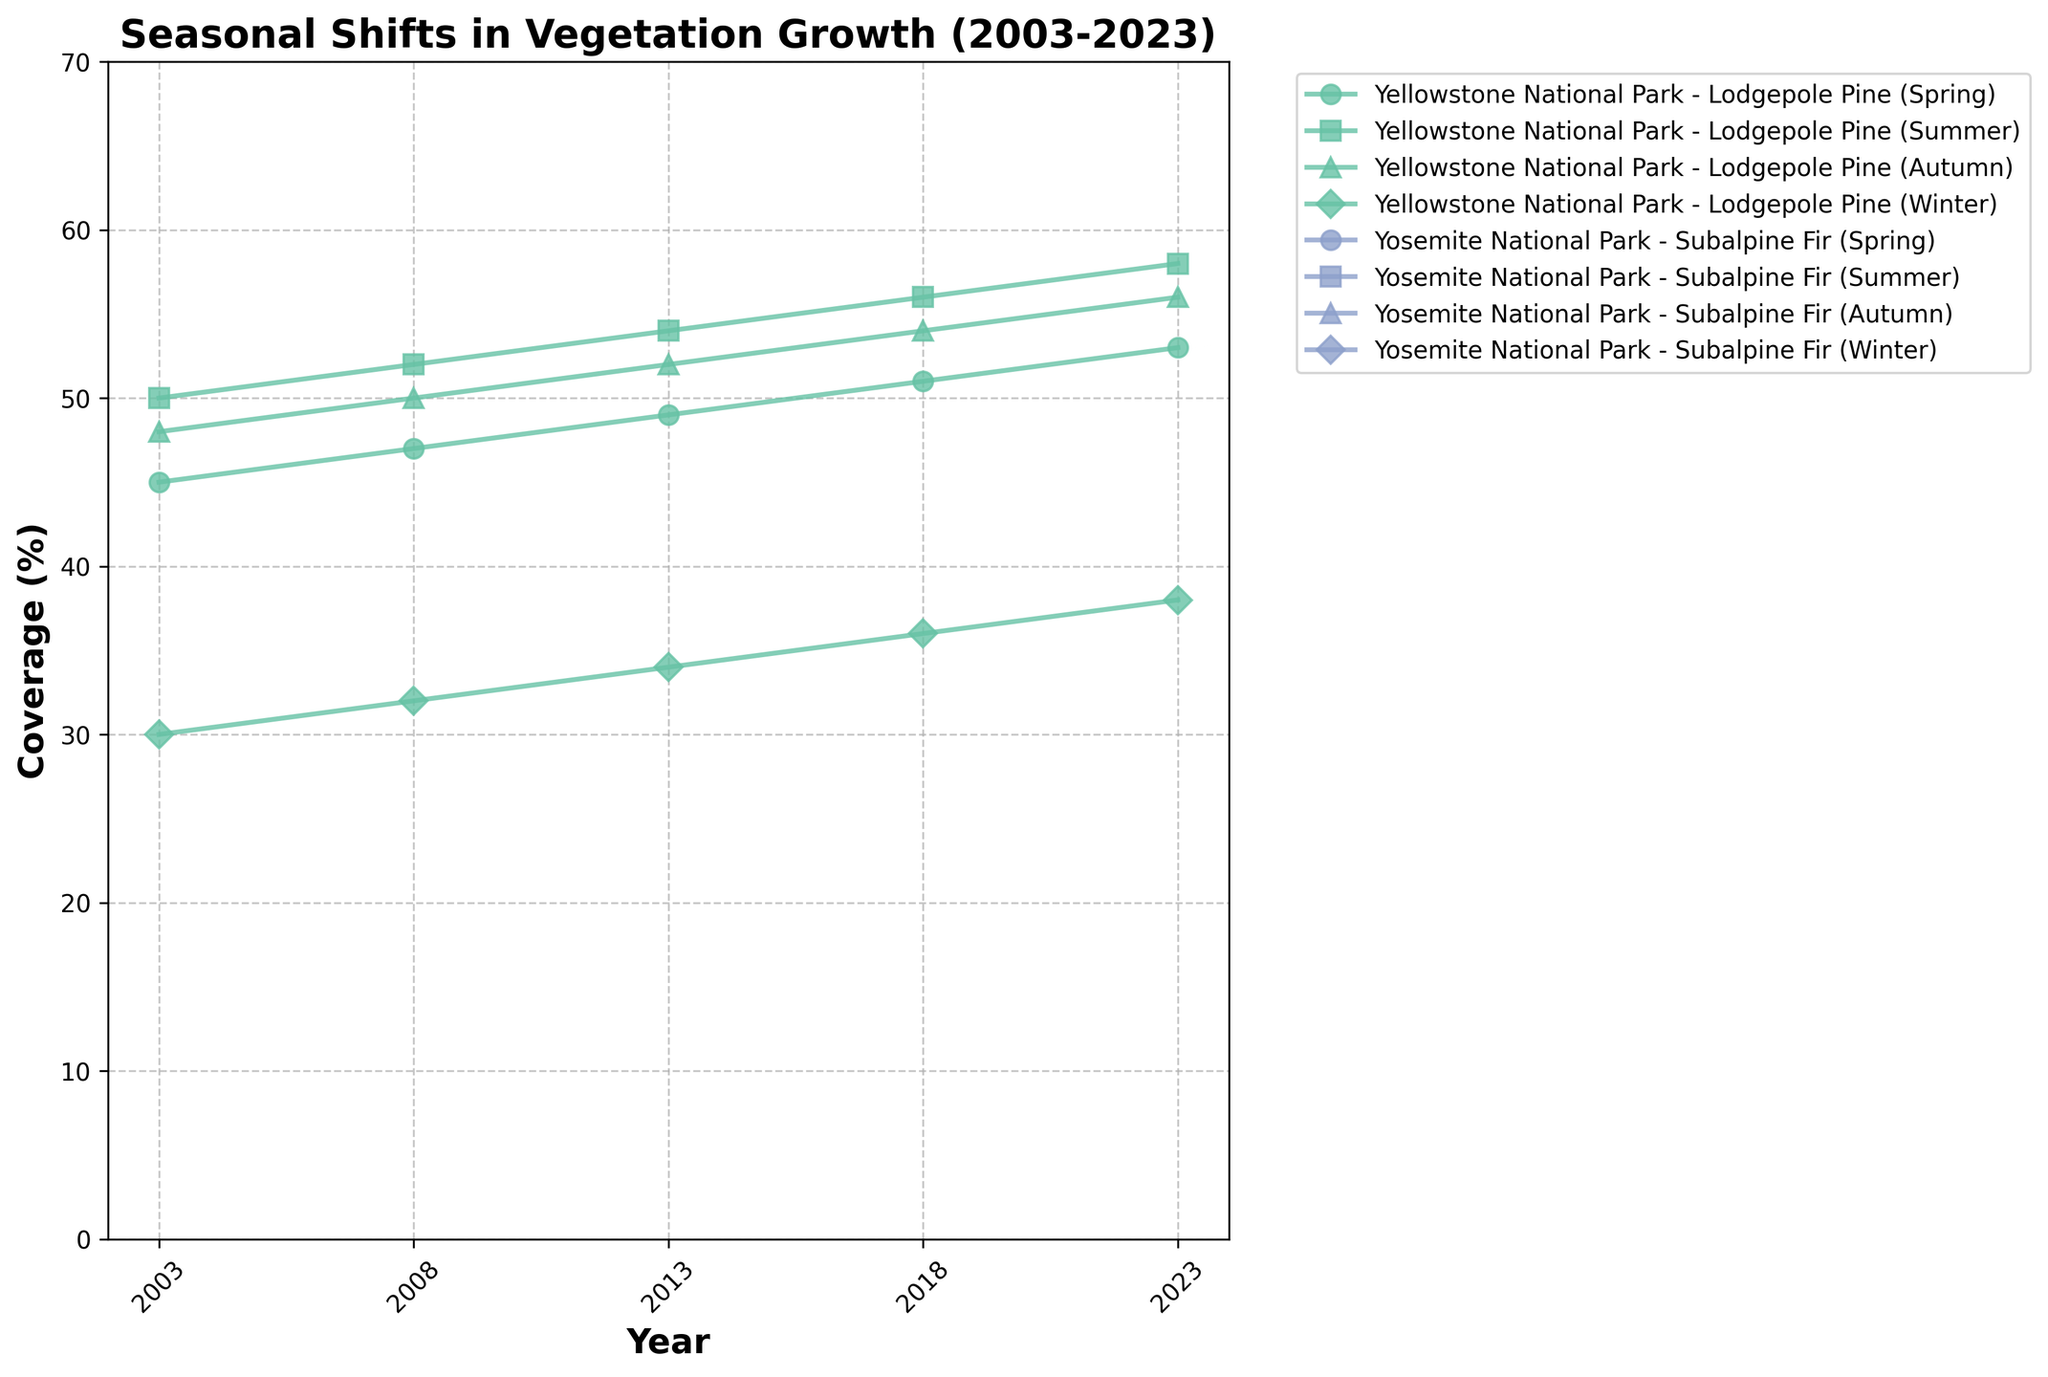What's the title of the figure? The title is usually located at the top of the figure, summarizing its content. In this figure, the title reads "Seasonal Shifts in Vegetation Growth (2003-2023)."
Answer: Seasonal Shifts in Vegetation Growth (2003-2023) What are the axis labels? The axes labels provide information about what is being measured. The x-axis is labeled "Year," and the y-axis is labeled "Coverage (%)".
Answer: Year, Coverage (%) How many species are tracked in the data? The legend contains information on all the species. Each unique label after the location-newline pattern represents a different species. Four species: Lodgepole Pine, Subalpine Fir, Ponderosa Pine, California Black Oak.
Answer: Four During which year is the summer coverage of Ponderosa Pine in Yosemite National Park the highest? By examining the line corresponding to "Yosemite National Park - Ponderosa Pine (Summer)", the peak coverage occurs in the year 2023.
Answer: 2023 What is the difference in winter coverage for Lodgepole Pine in Yellowstone National Park between 2003 and 2023? Observe the start and end points on the "Yellowstone National Park - Lodgepole Pine (Winter)" line. In 2003, coverage is 30, and in 2023, it is 38. The difference is 38 - 30.
Answer: 8 Which season shows the smallest change in coverage for Subalpine Fir in Yellowstone National Park? Review all seasonal lines for "Yellowstone National Park - Subalpine Fir" from 2003 to 2023. The winter line changes from 15 to 23, a difference of 8 units, smaller compared to other seasons.
Answer: Winter In 2023, which species has the highest autumn coverage in Yellowstone National Park, and what is it? Find the "Yellowstone National Park" legend lines for autumn coverage in 2023. The highest peak is on "Lodgepole Pine" line at 56%.
Answer: Lodgepole Pine, 56% What's the average summer coverage of California Black Oak in Yosemite National Park across all recorded years? Add all summer coverage values for "California Black Oak" in Yosemite for years 2003 (40), 2008 (42), 2013 (44), 2018 (46), and 2023 (48). Divide the sum by the number of years: (40 + 42 + 44 + 46 + 48) / 5.
Answer: 44 Which location/species/season combination experiences the largest increase in coverage over the 20 years? For each combination, determine the coverage difference between 2003 and 2023. The largest difference corresponds to "Yellowstone National Park - Lodgepole Pine (Summer)" with an 8% increase from 50 to 58.
Answer: Yellowstone National Park - Lodgepole Pine (Summer) 